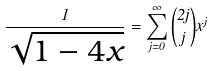<formula> <loc_0><loc_0><loc_500><loc_500>\frac { 1 } { \sqrt { 1 - 4 x } } = \sum _ { j = 0 } ^ { \infty } \binom { 2 j } { j } x ^ { j }</formula> 